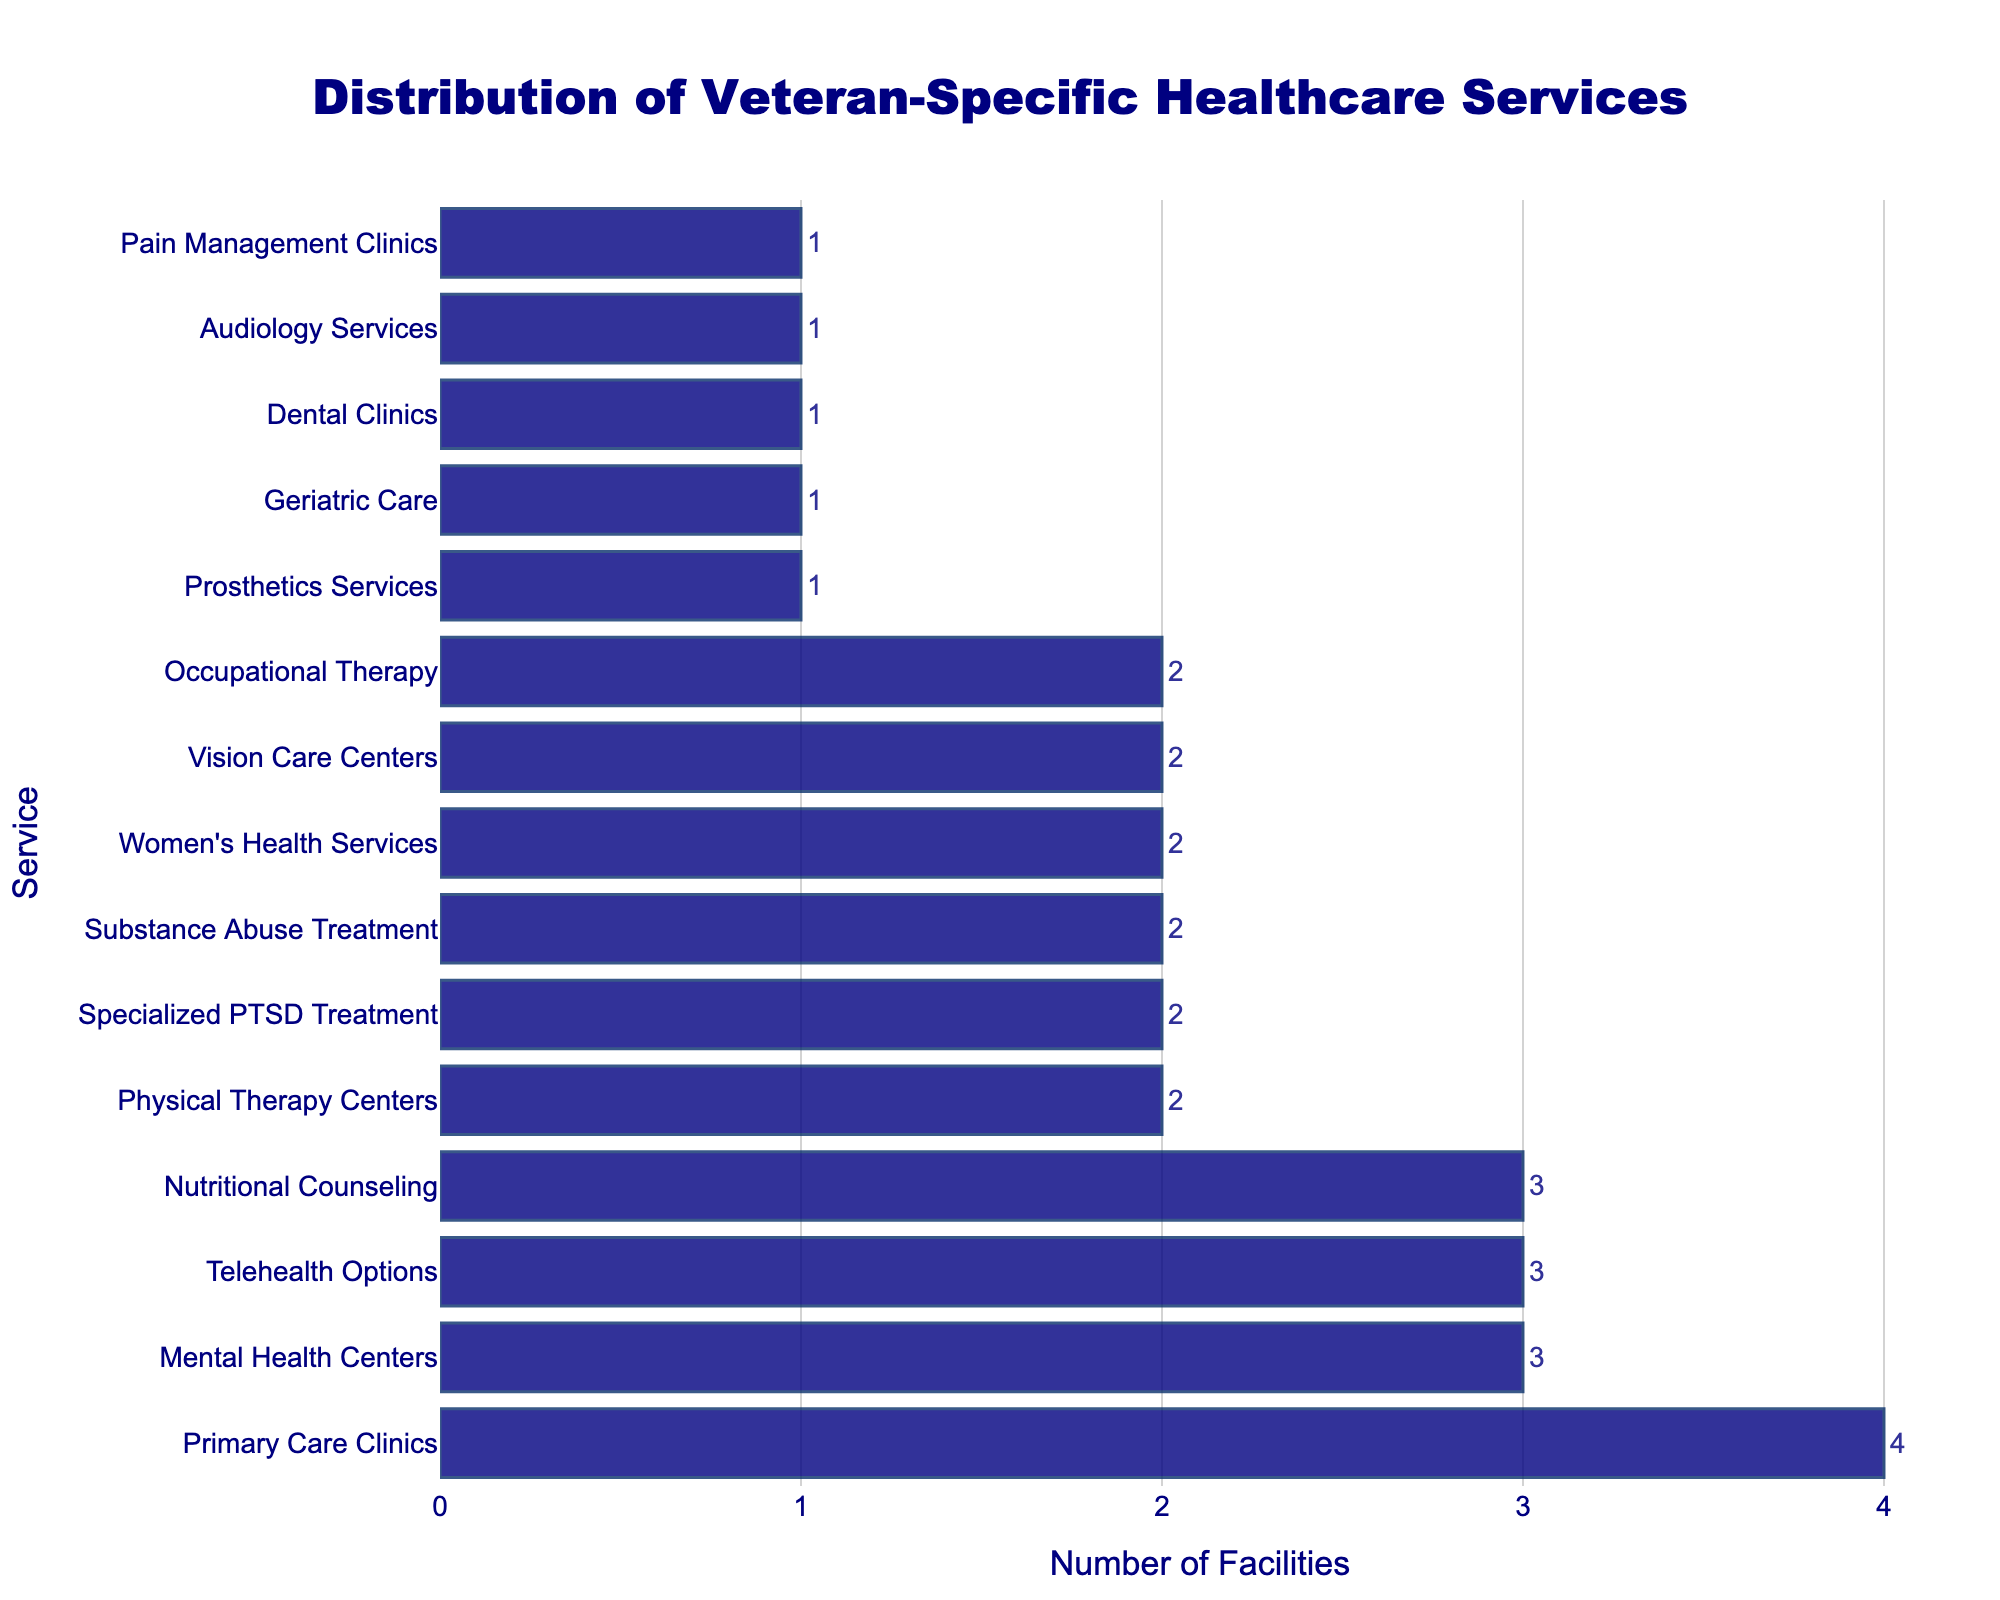How many services have exactly two facilities available? First, identify all the bars that reach the value of 2 on the x-axis. Count the number of these bars to get the answer. There are six services with exactly two facilities available: Physical Therapy Centers, Specialized PTSD Treatment, Substance Abuse Treatment, Women's Health Services, Vision Care Centers, and Occupational Therapy.
Answer: 6 Which service has the highest number of facilities? Look at the bar that extends the furthest to the right on the x-axis, indicating the highest value. The Primary Care Clinics bar is the longest, indicating that it has the highest number of facilities.
Answer: Primary Care Clinics Are there more services with three facilities or with one facility? Count the number of bars that extend to 3 on the x-axis and compare it to the number of bars that extend to 1. Three services have three facilities: Mental Health Centers, Telehealth Options, and Nutritional Counseling. Five services have one facility: Prosthetics Services, Geriatric Care, Dental Clinics, Audiology Services, and Pain Management Clinics.
Answer: More services with one facility What is the total number of facilities for all services combined? Add the number of facilities for each service. The total is: 4 + 3 + 2 + 1 + 2 + 2 + 1 + 2 + 3 + 1 + 2 + 1 + 2 + 3 + 1 = 30.
Answer: 30 Which services have fewer facilities than Telehealth Options? Identify the number of facilities for Telehealth Options (which is 3), then list all services with fewer than 3 facilities. These services are: Physical Therapy Centers, Prosthetics Services, Specialized PTSD Treatment, Substance Abuse Treatment, Geriatric Care, Women's Health Services, Dental Clinics, Vision Care Centers, Audiology Services, Occupational Therapy, Pain Management Clinics.
Answer: 11 services How many more Primary Care Clinics are there compared to Prosthetics Services? Identify the number of facilities for Primary Care Clinics (4) and Prosthetics Services (1). Subtract the number of Prosthetics Services from the number of Primary Care Clinics. The difference is 4 - 1 = 3.
Answer: 3 What is the average number of facilities per service? Divide the total number of facilities (30) by the number of distinct services (15). The average is 30 / 15 = 2.
Answer: 2 Which has more facilities: Geriatric Care or Dental Clinics? Find the number of facilities for both Geriatric Care and Dental Clinics. Both Geriatric Care and Dental Clinics have 1 facility each, so they have an equal number.
Answer: Equal How many services have either one or three facilities? Identify all services with exactly one and three facilities. Count the bars for each case and add them together. The services with one facility are Prosthetics Services, Geriatric Care, Dental Clinics, Audiology Services, and Pain Management Clinics (5). The services with three facilities are Mental Health Centers, Telehealth Options, and Nutritional Counseling (3). So, 5 + 3 = 8 services have either one or three facilities.
Answer: 8 What visual feature indicates the number of facilities available for each service? Observe the length of each bar in the chart. Longer bars represent a greater number of facilities. The number associated with each bar on the x-axis specifies the exact count.
Answer: Length of bars 